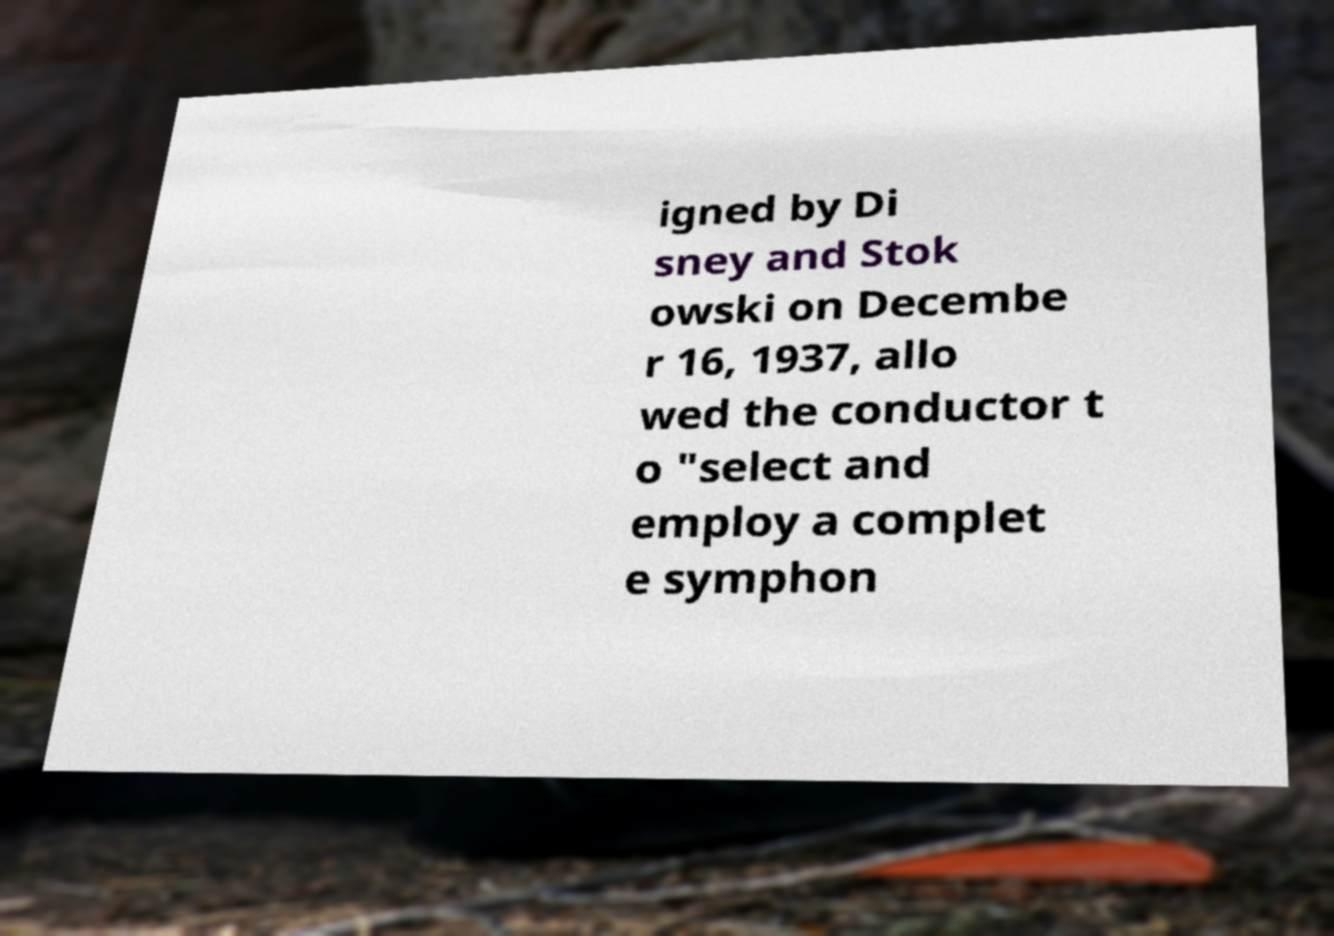I need the written content from this picture converted into text. Can you do that? igned by Di sney and Stok owski on Decembe r 16, 1937, allo wed the conductor t o "select and employ a complet e symphon 